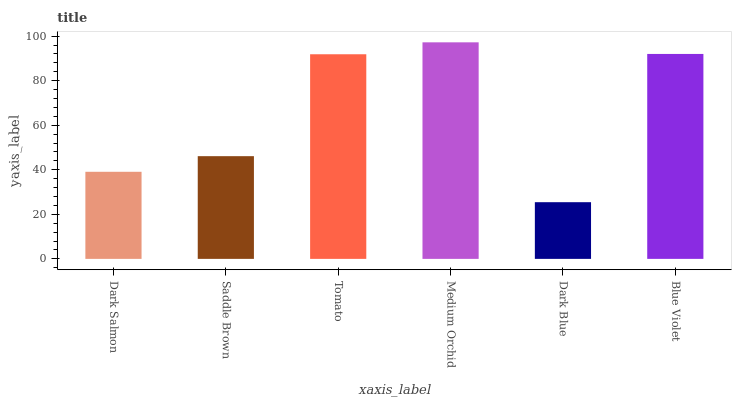Is Dark Blue the minimum?
Answer yes or no. Yes. Is Medium Orchid the maximum?
Answer yes or no. Yes. Is Saddle Brown the minimum?
Answer yes or no. No. Is Saddle Brown the maximum?
Answer yes or no. No. Is Saddle Brown greater than Dark Salmon?
Answer yes or no. Yes. Is Dark Salmon less than Saddle Brown?
Answer yes or no. Yes. Is Dark Salmon greater than Saddle Brown?
Answer yes or no. No. Is Saddle Brown less than Dark Salmon?
Answer yes or no. No. Is Tomato the high median?
Answer yes or no. Yes. Is Saddle Brown the low median?
Answer yes or no. Yes. Is Dark Salmon the high median?
Answer yes or no. No. Is Blue Violet the low median?
Answer yes or no. No. 